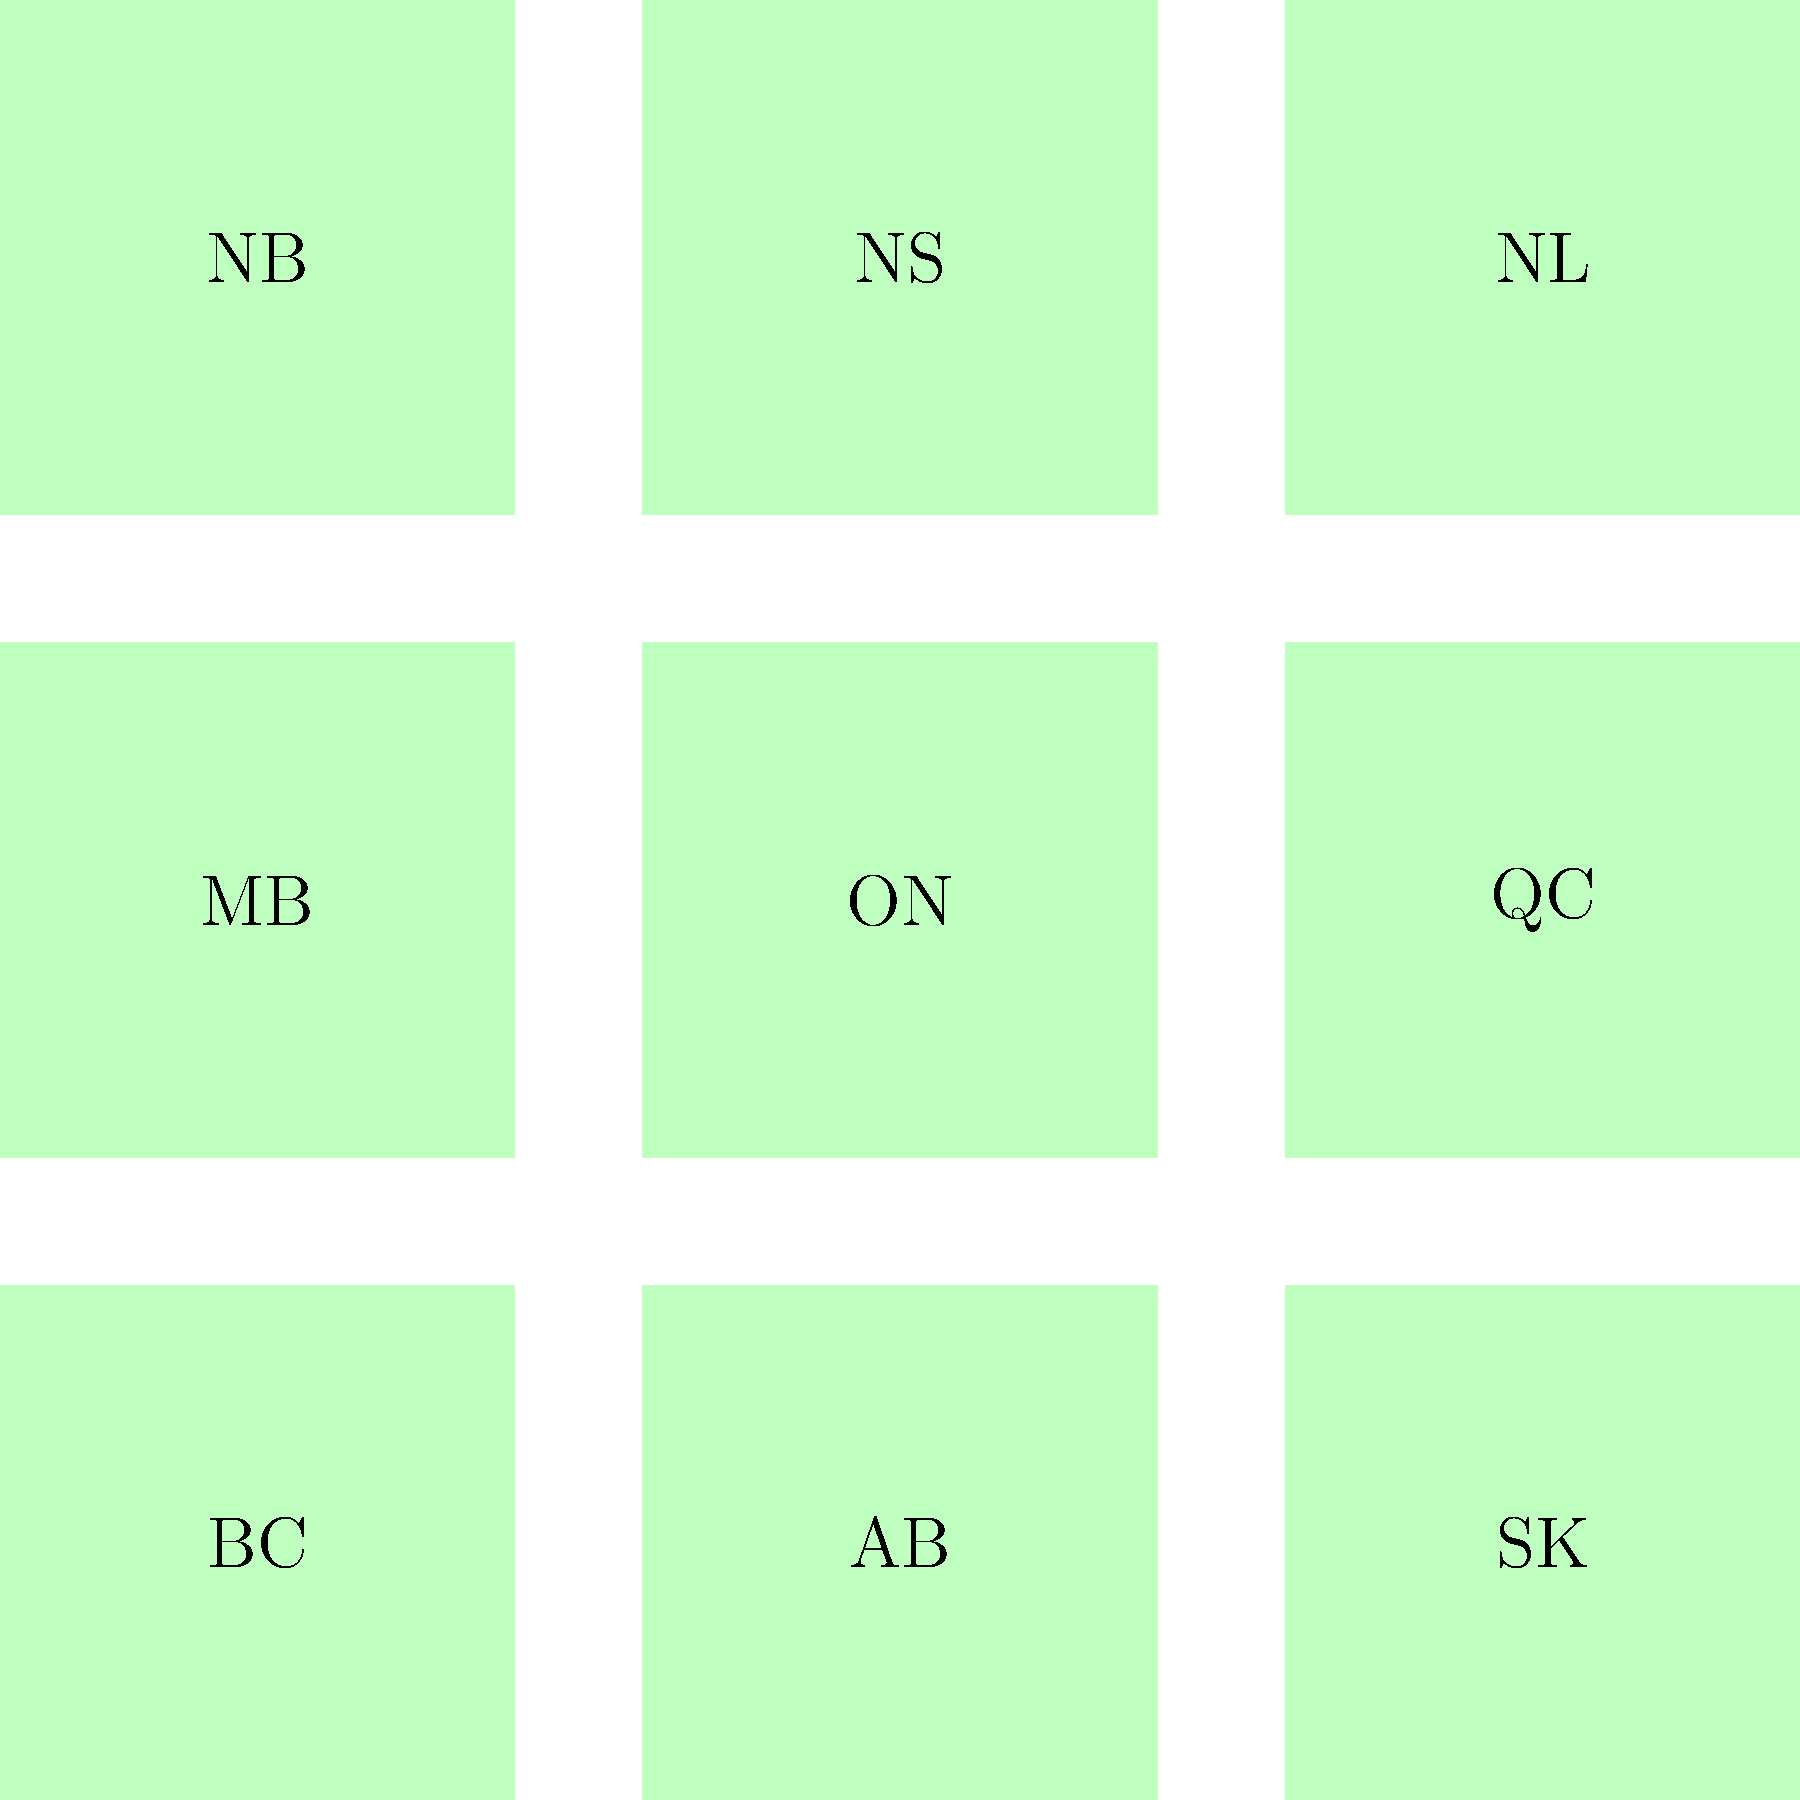Based on the map and pie charts representing the distribution of Indigenous languages in Canadian provinces, which province shows the highest percentage of Cree speakers, and how does this compare to the distribution in Ontario? To answer this question, we need to analyze the pie charts for the provinces shown:

1. Identify the provinces with pie charts:
   - British Columbia (BC)
   - Quebec (QC)
   - Ontario (ON)

2. Interpret the pie chart legend:
   - Red represents Cree
   - Blue represents Ojibwe
   - Green represents Other languages

3. Compare the red (Cree) sections of each pie chart:
   - BC: approximately 60%
   - QC: approximately 80%
   - ON: approximately 70%

4. Identify the province with the highest percentage of Cree speakers:
   Quebec (QC) has the largest red section, indicating about 80% Cree speakers.

5. Compare Quebec's Cree percentage to Ontario:
   - Quebec: ~80% Cree
   - Ontario: ~70% Cree
   The difference is approximately 10 percentage points.
Answer: Quebec; 10 percentage points higher than Ontario 